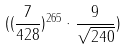<formula> <loc_0><loc_0><loc_500><loc_500>( ( \frac { 7 } { 4 2 8 } ) ^ { 2 6 5 } \cdot \frac { 9 } { \sqrt { 2 4 0 } } )</formula> 